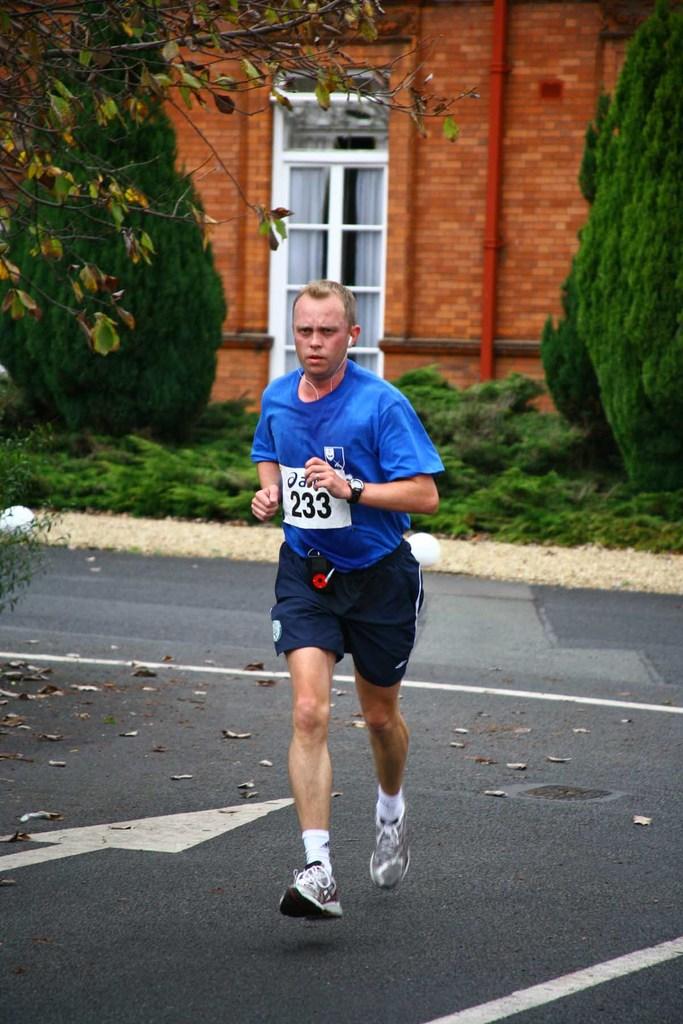What number is on this guy's chest?
Ensure brevity in your answer.  233. 